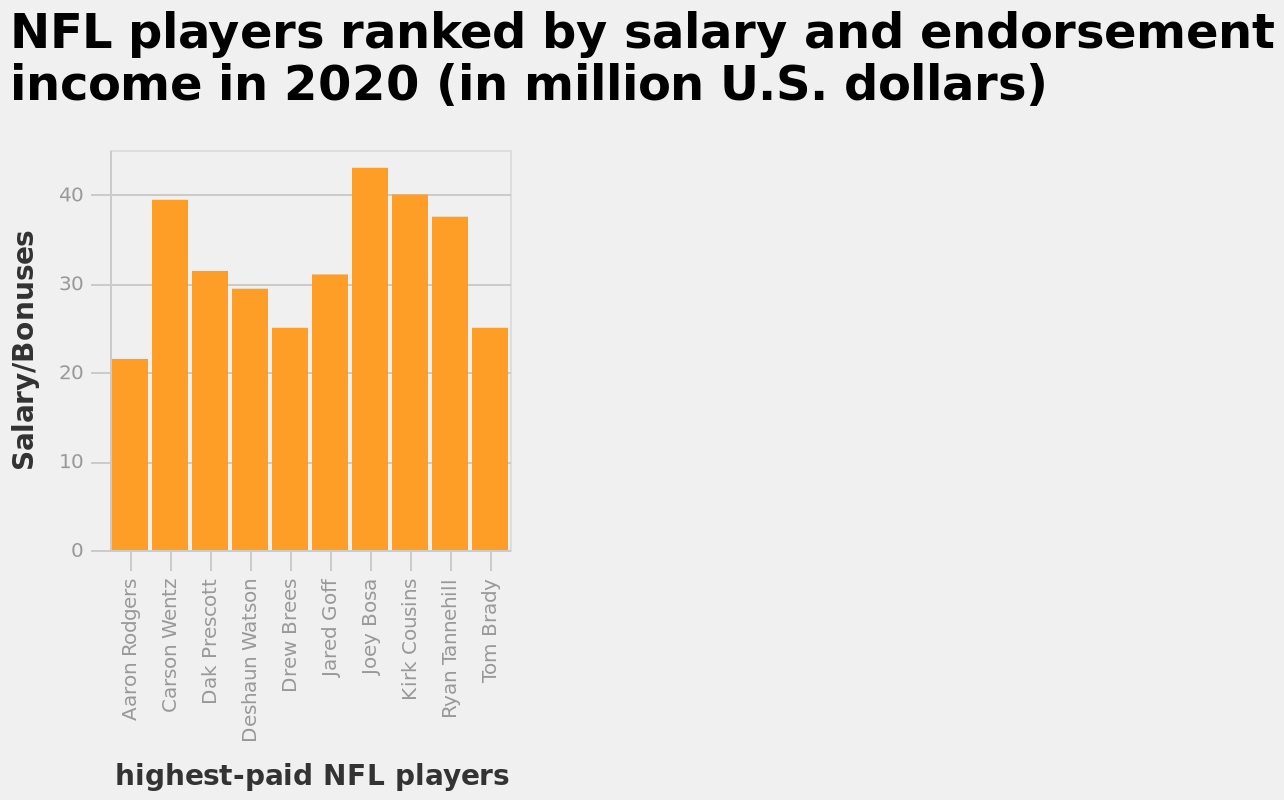<image>
What does the bar plot depict? The bar plot depicts the ranking of NFL players based on their salary and endorsement income in 2020. please summary the statistics and relations of the chart All NFL players are earning a salary above 20 million dollars with 60% achieving a salary above 30 million dollars. What is the unit of measurement for the salary and endorsement income on the bar plot? The unit of measurement for the salary and endorsement income on the bar plot is million U.S. dollars. 